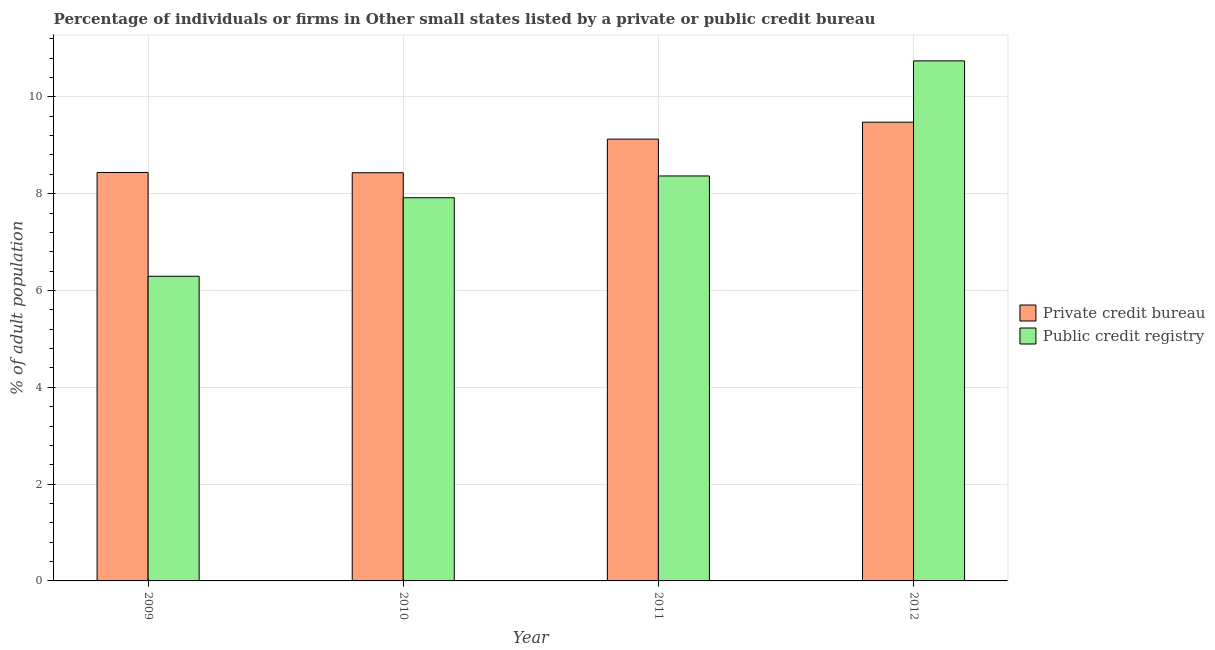How many different coloured bars are there?
Provide a short and direct response. 2. Are the number of bars per tick equal to the number of legend labels?
Offer a very short reply. Yes. Are the number of bars on each tick of the X-axis equal?
Your response must be concise. Yes. How many bars are there on the 2nd tick from the right?
Offer a very short reply. 2. What is the percentage of firms listed by public credit bureau in 2009?
Offer a terse response. 6.29. Across all years, what is the maximum percentage of firms listed by public credit bureau?
Give a very brief answer. 10.74. Across all years, what is the minimum percentage of firms listed by private credit bureau?
Provide a succinct answer. 8.43. What is the total percentage of firms listed by public credit bureau in the graph?
Keep it short and to the point. 33.32. What is the difference between the percentage of firms listed by public credit bureau in 2009 and that in 2012?
Provide a short and direct response. -4.45. What is the difference between the percentage of firms listed by private credit bureau in 2009 and the percentage of firms listed by public credit bureau in 2010?
Make the answer very short. 0.01. What is the average percentage of firms listed by private credit bureau per year?
Your response must be concise. 8.87. In how many years, is the percentage of firms listed by public credit bureau greater than 7.6 %?
Keep it short and to the point. 3. What is the ratio of the percentage of firms listed by public credit bureau in 2009 to that in 2012?
Provide a succinct answer. 0.59. Is the percentage of firms listed by private credit bureau in 2010 less than that in 2012?
Give a very brief answer. Yes. Is the difference between the percentage of firms listed by public credit bureau in 2009 and 2011 greater than the difference between the percentage of firms listed by private credit bureau in 2009 and 2011?
Provide a short and direct response. No. What is the difference between the highest and the second highest percentage of firms listed by private credit bureau?
Keep it short and to the point. 0.35. What is the difference between the highest and the lowest percentage of firms listed by private credit bureau?
Ensure brevity in your answer.  1.04. In how many years, is the percentage of firms listed by public credit bureau greater than the average percentage of firms listed by public credit bureau taken over all years?
Provide a short and direct response. 2. Is the sum of the percentage of firms listed by public credit bureau in 2010 and 2011 greater than the maximum percentage of firms listed by private credit bureau across all years?
Keep it short and to the point. Yes. What does the 2nd bar from the left in 2012 represents?
Offer a terse response. Public credit registry. What does the 2nd bar from the right in 2010 represents?
Your answer should be very brief. Private credit bureau. Are all the bars in the graph horizontal?
Provide a short and direct response. No. How many years are there in the graph?
Your response must be concise. 4. Are the values on the major ticks of Y-axis written in scientific E-notation?
Offer a terse response. No. Does the graph contain grids?
Give a very brief answer. Yes. Where does the legend appear in the graph?
Your answer should be very brief. Center right. What is the title of the graph?
Offer a terse response. Percentage of individuals or firms in Other small states listed by a private or public credit bureau. What is the label or title of the Y-axis?
Offer a terse response. % of adult population. What is the % of adult population in Private credit bureau in 2009?
Provide a short and direct response. 8.44. What is the % of adult population in Public credit registry in 2009?
Offer a terse response. 6.29. What is the % of adult population of Private credit bureau in 2010?
Make the answer very short. 8.43. What is the % of adult population of Public credit registry in 2010?
Give a very brief answer. 7.92. What is the % of adult population of Private credit bureau in 2011?
Your answer should be compact. 9.13. What is the % of adult population in Public credit registry in 2011?
Your answer should be very brief. 8.37. What is the % of adult population in Private credit bureau in 2012?
Give a very brief answer. 9.48. What is the % of adult population of Public credit registry in 2012?
Provide a succinct answer. 10.74. Across all years, what is the maximum % of adult population of Private credit bureau?
Ensure brevity in your answer.  9.48. Across all years, what is the maximum % of adult population in Public credit registry?
Your answer should be very brief. 10.74. Across all years, what is the minimum % of adult population of Private credit bureau?
Give a very brief answer. 8.43. Across all years, what is the minimum % of adult population in Public credit registry?
Keep it short and to the point. 6.29. What is the total % of adult population in Private credit bureau in the graph?
Your response must be concise. 35.48. What is the total % of adult population in Public credit registry in the graph?
Provide a short and direct response. 33.32. What is the difference between the % of adult population in Private credit bureau in 2009 and that in 2010?
Your answer should be very brief. 0.01. What is the difference between the % of adult population of Public credit registry in 2009 and that in 2010?
Offer a terse response. -1.62. What is the difference between the % of adult population of Private credit bureau in 2009 and that in 2011?
Keep it short and to the point. -0.69. What is the difference between the % of adult population of Public credit registry in 2009 and that in 2011?
Provide a short and direct response. -2.07. What is the difference between the % of adult population of Private credit bureau in 2009 and that in 2012?
Ensure brevity in your answer.  -1.04. What is the difference between the % of adult population in Public credit registry in 2009 and that in 2012?
Give a very brief answer. -4.45. What is the difference between the % of adult population of Private credit bureau in 2010 and that in 2011?
Your answer should be compact. -0.69. What is the difference between the % of adult population of Public credit registry in 2010 and that in 2011?
Make the answer very short. -0.45. What is the difference between the % of adult population of Private credit bureau in 2010 and that in 2012?
Provide a succinct answer. -1.04. What is the difference between the % of adult population of Public credit registry in 2010 and that in 2012?
Offer a terse response. -2.83. What is the difference between the % of adult population in Private credit bureau in 2011 and that in 2012?
Provide a short and direct response. -0.35. What is the difference between the % of adult population in Public credit registry in 2011 and that in 2012?
Make the answer very short. -2.38. What is the difference between the % of adult population in Private credit bureau in 2009 and the % of adult population in Public credit registry in 2010?
Your response must be concise. 0.52. What is the difference between the % of adult population of Private credit bureau in 2009 and the % of adult population of Public credit registry in 2011?
Your answer should be compact. 0.07. What is the difference between the % of adult population in Private credit bureau in 2009 and the % of adult population in Public credit registry in 2012?
Offer a very short reply. -2.31. What is the difference between the % of adult population of Private credit bureau in 2010 and the % of adult population of Public credit registry in 2011?
Keep it short and to the point. 0.07. What is the difference between the % of adult population of Private credit bureau in 2010 and the % of adult population of Public credit registry in 2012?
Offer a terse response. -2.31. What is the difference between the % of adult population in Private credit bureau in 2011 and the % of adult population in Public credit registry in 2012?
Give a very brief answer. -1.62. What is the average % of adult population of Private credit bureau per year?
Offer a very short reply. 8.87. What is the average % of adult population of Public credit registry per year?
Provide a succinct answer. 8.33. In the year 2009, what is the difference between the % of adult population of Private credit bureau and % of adult population of Public credit registry?
Provide a succinct answer. 2.14. In the year 2010, what is the difference between the % of adult population of Private credit bureau and % of adult population of Public credit registry?
Make the answer very short. 0.52. In the year 2011, what is the difference between the % of adult population in Private credit bureau and % of adult population in Public credit registry?
Ensure brevity in your answer.  0.76. In the year 2012, what is the difference between the % of adult population in Private credit bureau and % of adult population in Public credit registry?
Ensure brevity in your answer.  -1.27. What is the ratio of the % of adult population of Private credit bureau in 2009 to that in 2010?
Your answer should be compact. 1. What is the ratio of the % of adult population of Public credit registry in 2009 to that in 2010?
Provide a short and direct response. 0.8. What is the ratio of the % of adult population of Private credit bureau in 2009 to that in 2011?
Give a very brief answer. 0.92. What is the ratio of the % of adult population in Public credit registry in 2009 to that in 2011?
Give a very brief answer. 0.75. What is the ratio of the % of adult population of Private credit bureau in 2009 to that in 2012?
Your answer should be compact. 0.89. What is the ratio of the % of adult population of Public credit registry in 2009 to that in 2012?
Your answer should be compact. 0.59. What is the ratio of the % of adult population in Private credit bureau in 2010 to that in 2011?
Provide a short and direct response. 0.92. What is the ratio of the % of adult population of Public credit registry in 2010 to that in 2011?
Make the answer very short. 0.95. What is the ratio of the % of adult population of Private credit bureau in 2010 to that in 2012?
Offer a terse response. 0.89. What is the ratio of the % of adult population in Public credit registry in 2010 to that in 2012?
Your answer should be compact. 0.74. What is the ratio of the % of adult population of Private credit bureau in 2011 to that in 2012?
Make the answer very short. 0.96. What is the ratio of the % of adult population of Public credit registry in 2011 to that in 2012?
Keep it short and to the point. 0.78. What is the difference between the highest and the second highest % of adult population of Private credit bureau?
Provide a succinct answer. 0.35. What is the difference between the highest and the second highest % of adult population in Public credit registry?
Make the answer very short. 2.38. What is the difference between the highest and the lowest % of adult population in Private credit bureau?
Offer a very short reply. 1.04. What is the difference between the highest and the lowest % of adult population of Public credit registry?
Your response must be concise. 4.45. 